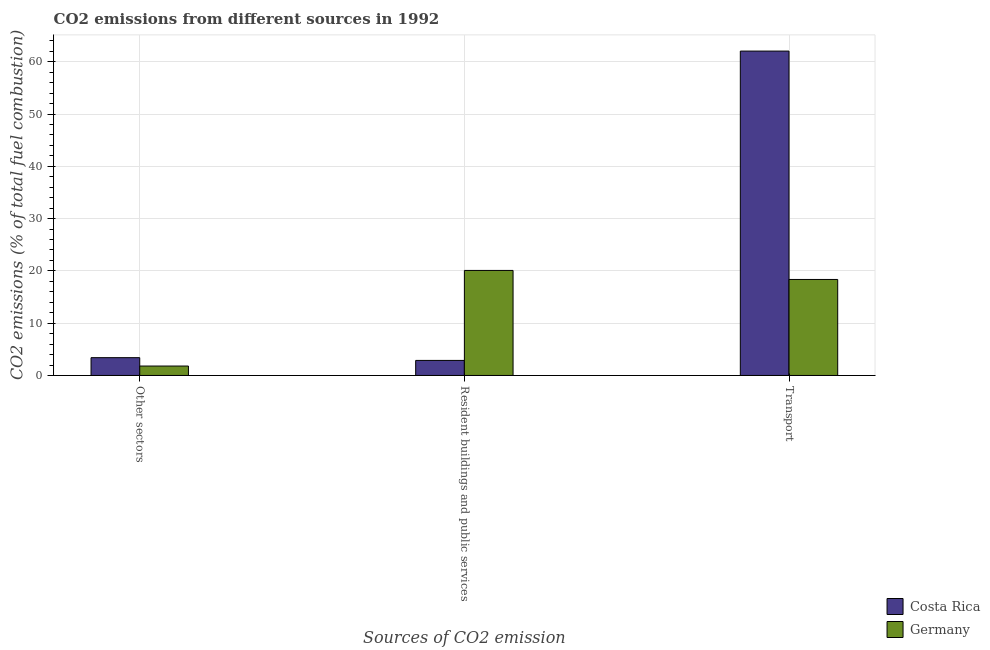How many groups of bars are there?
Your answer should be very brief. 3. Are the number of bars per tick equal to the number of legend labels?
Offer a terse response. Yes. What is the label of the 1st group of bars from the left?
Offer a terse response. Other sectors. What is the percentage of co2 emissions from transport in Costa Rica?
Your response must be concise. 62.04. Across all countries, what is the maximum percentage of co2 emissions from transport?
Your answer should be very brief. 62.04. Across all countries, what is the minimum percentage of co2 emissions from resident buildings and public services?
Keep it short and to the point. 2.88. In which country was the percentage of co2 emissions from resident buildings and public services maximum?
Offer a very short reply. Germany. What is the total percentage of co2 emissions from other sectors in the graph?
Your answer should be compact. 5.2. What is the difference between the percentage of co2 emissions from other sectors in Germany and that in Costa Rica?
Offer a very short reply. -1.6. What is the difference between the percentage of co2 emissions from other sectors in Costa Rica and the percentage of co2 emissions from resident buildings and public services in Germany?
Offer a terse response. -16.69. What is the average percentage of co2 emissions from resident buildings and public services per country?
Your answer should be compact. 11.48. What is the difference between the percentage of co2 emissions from other sectors and percentage of co2 emissions from transport in Germany?
Offer a very short reply. -16.56. What is the ratio of the percentage of co2 emissions from resident buildings and public services in Costa Rica to that in Germany?
Keep it short and to the point. 0.14. What is the difference between the highest and the second highest percentage of co2 emissions from other sectors?
Offer a very short reply. 1.6. What is the difference between the highest and the lowest percentage of co2 emissions from transport?
Make the answer very short. 43.68. In how many countries, is the percentage of co2 emissions from transport greater than the average percentage of co2 emissions from transport taken over all countries?
Provide a short and direct response. 1. Is the sum of the percentage of co2 emissions from transport in Costa Rica and Germany greater than the maximum percentage of co2 emissions from other sectors across all countries?
Offer a terse response. Yes. What does the 2nd bar from the left in Other sectors represents?
Offer a very short reply. Germany. What does the 2nd bar from the right in Resident buildings and public services represents?
Give a very brief answer. Costa Rica. Is it the case that in every country, the sum of the percentage of co2 emissions from other sectors and percentage of co2 emissions from resident buildings and public services is greater than the percentage of co2 emissions from transport?
Offer a very short reply. No. How many bars are there?
Your response must be concise. 6. What is the difference between two consecutive major ticks on the Y-axis?
Offer a very short reply. 10. Are the values on the major ticks of Y-axis written in scientific E-notation?
Your answer should be compact. No. How many legend labels are there?
Your answer should be compact. 2. How are the legend labels stacked?
Offer a terse response. Vertical. What is the title of the graph?
Your answer should be very brief. CO2 emissions from different sources in 1992. What is the label or title of the X-axis?
Ensure brevity in your answer.  Sources of CO2 emission. What is the label or title of the Y-axis?
Your answer should be compact. CO2 emissions (% of total fuel combustion). What is the CO2 emissions (% of total fuel combustion) in Costa Rica in Other sectors?
Make the answer very short. 3.4. What is the CO2 emissions (% of total fuel combustion) of Germany in Other sectors?
Provide a short and direct response. 1.8. What is the CO2 emissions (% of total fuel combustion) of Costa Rica in Resident buildings and public services?
Keep it short and to the point. 2.88. What is the CO2 emissions (% of total fuel combustion) in Germany in Resident buildings and public services?
Your answer should be compact. 20.09. What is the CO2 emissions (% of total fuel combustion) in Costa Rica in Transport?
Ensure brevity in your answer.  62.04. What is the CO2 emissions (% of total fuel combustion) in Germany in Transport?
Offer a terse response. 18.36. Across all Sources of CO2 emission, what is the maximum CO2 emissions (% of total fuel combustion) in Costa Rica?
Your answer should be compact. 62.04. Across all Sources of CO2 emission, what is the maximum CO2 emissions (% of total fuel combustion) in Germany?
Offer a terse response. 20.09. Across all Sources of CO2 emission, what is the minimum CO2 emissions (% of total fuel combustion) in Costa Rica?
Keep it short and to the point. 2.88. Across all Sources of CO2 emission, what is the minimum CO2 emissions (% of total fuel combustion) of Germany?
Provide a succinct answer. 1.8. What is the total CO2 emissions (% of total fuel combustion) in Costa Rica in the graph?
Offer a terse response. 68.32. What is the total CO2 emissions (% of total fuel combustion) of Germany in the graph?
Provide a short and direct response. 40.25. What is the difference between the CO2 emissions (% of total fuel combustion) of Costa Rica in Other sectors and that in Resident buildings and public services?
Offer a very short reply. 0.52. What is the difference between the CO2 emissions (% of total fuel combustion) in Germany in Other sectors and that in Resident buildings and public services?
Ensure brevity in your answer.  -18.29. What is the difference between the CO2 emissions (% of total fuel combustion) in Costa Rica in Other sectors and that in Transport?
Your answer should be very brief. -58.64. What is the difference between the CO2 emissions (% of total fuel combustion) in Germany in Other sectors and that in Transport?
Give a very brief answer. -16.56. What is the difference between the CO2 emissions (% of total fuel combustion) in Costa Rica in Resident buildings and public services and that in Transport?
Ensure brevity in your answer.  -59.16. What is the difference between the CO2 emissions (% of total fuel combustion) of Germany in Resident buildings and public services and that in Transport?
Your response must be concise. 1.73. What is the difference between the CO2 emissions (% of total fuel combustion) of Costa Rica in Other sectors and the CO2 emissions (% of total fuel combustion) of Germany in Resident buildings and public services?
Provide a short and direct response. -16.69. What is the difference between the CO2 emissions (% of total fuel combustion) of Costa Rica in Other sectors and the CO2 emissions (% of total fuel combustion) of Germany in Transport?
Give a very brief answer. -14.96. What is the difference between the CO2 emissions (% of total fuel combustion) in Costa Rica in Resident buildings and public services and the CO2 emissions (% of total fuel combustion) in Germany in Transport?
Make the answer very short. -15.48. What is the average CO2 emissions (% of total fuel combustion) in Costa Rica per Sources of CO2 emission?
Offer a terse response. 22.77. What is the average CO2 emissions (% of total fuel combustion) of Germany per Sources of CO2 emission?
Give a very brief answer. 13.42. What is the difference between the CO2 emissions (% of total fuel combustion) of Costa Rica and CO2 emissions (% of total fuel combustion) of Germany in Other sectors?
Offer a very short reply. 1.6. What is the difference between the CO2 emissions (% of total fuel combustion) of Costa Rica and CO2 emissions (% of total fuel combustion) of Germany in Resident buildings and public services?
Provide a succinct answer. -17.21. What is the difference between the CO2 emissions (% of total fuel combustion) in Costa Rica and CO2 emissions (% of total fuel combustion) in Germany in Transport?
Your response must be concise. 43.68. What is the ratio of the CO2 emissions (% of total fuel combustion) of Costa Rica in Other sectors to that in Resident buildings and public services?
Ensure brevity in your answer.  1.18. What is the ratio of the CO2 emissions (% of total fuel combustion) of Germany in Other sectors to that in Resident buildings and public services?
Your answer should be compact. 0.09. What is the ratio of the CO2 emissions (% of total fuel combustion) in Costa Rica in Other sectors to that in Transport?
Ensure brevity in your answer.  0.05. What is the ratio of the CO2 emissions (% of total fuel combustion) of Germany in Other sectors to that in Transport?
Provide a succinct answer. 0.1. What is the ratio of the CO2 emissions (% of total fuel combustion) in Costa Rica in Resident buildings and public services to that in Transport?
Provide a short and direct response. 0.05. What is the ratio of the CO2 emissions (% of total fuel combustion) in Germany in Resident buildings and public services to that in Transport?
Provide a succinct answer. 1.09. What is the difference between the highest and the second highest CO2 emissions (% of total fuel combustion) of Costa Rica?
Ensure brevity in your answer.  58.64. What is the difference between the highest and the second highest CO2 emissions (% of total fuel combustion) of Germany?
Your response must be concise. 1.73. What is the difference between the highest and the lowest CO2 emissions (% of total fuel combustion) of Costa Rica?
Make the answer very short. 59.16. What is the difference between the highest and the lowest CO2 emissions (% of total fuel combustion) in Germany?
Your response must be concise. 18.29. 